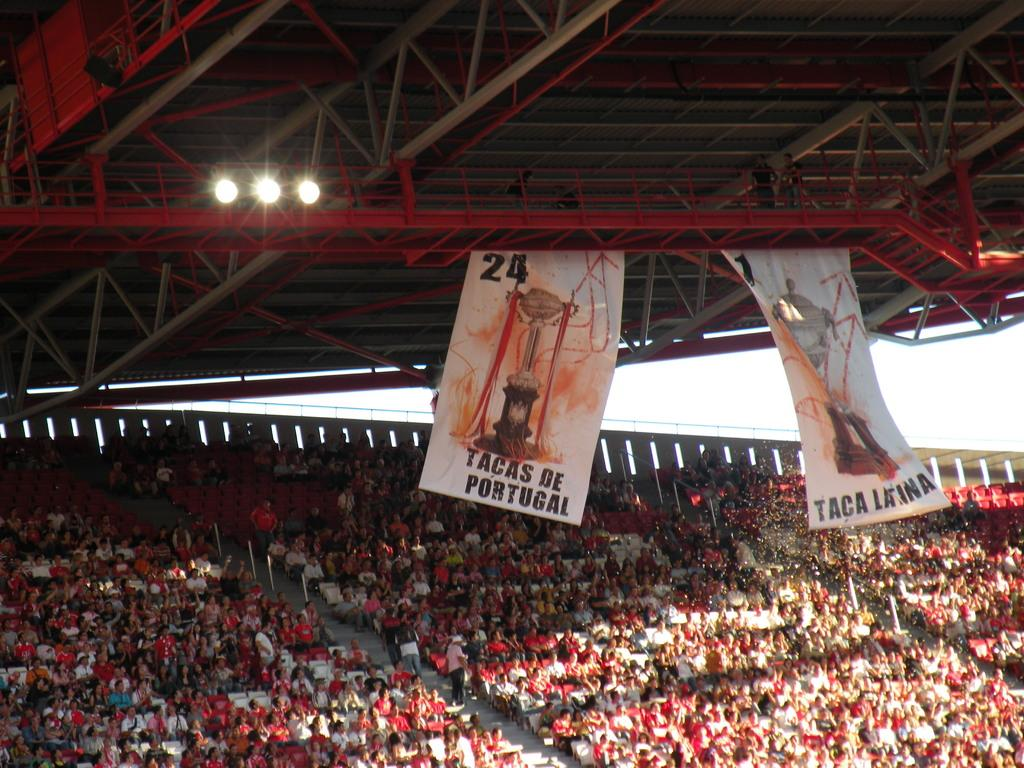<image>
Create a compact narrative representing the image presented. banners showing tacaas de portugal are hung from the top of the stadium 